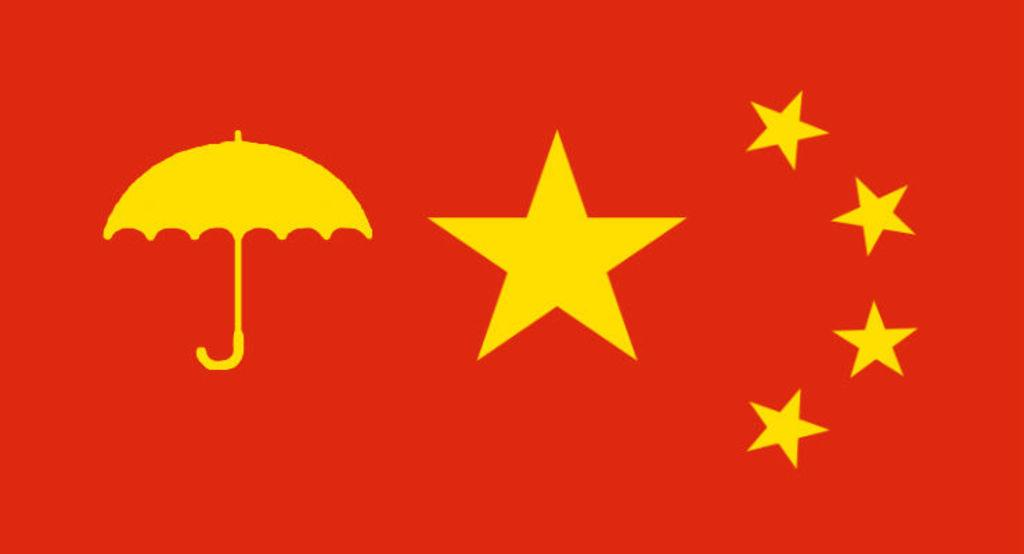What object can be seen in the picture? There is an umbrella in the picture. What celestial objects are visible in the picture? Stars are visible in the picture. What is the color of the backdrop in the image? The backdrop of the image is in red color. What type of alarm can be heard in the image? There is no alarm present in the image, as it is a still picture. How does the umbrella say good-bye to the stars in the image? The umbrella and stars are inanimate objects and cannot communicate or say good-bye in the image. 